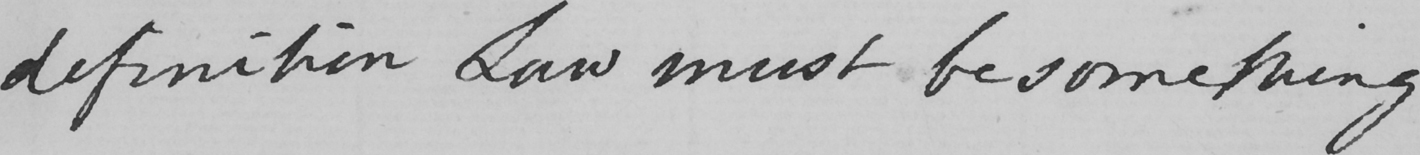Can you read and transcribe this handwriting? definition Law must be something 